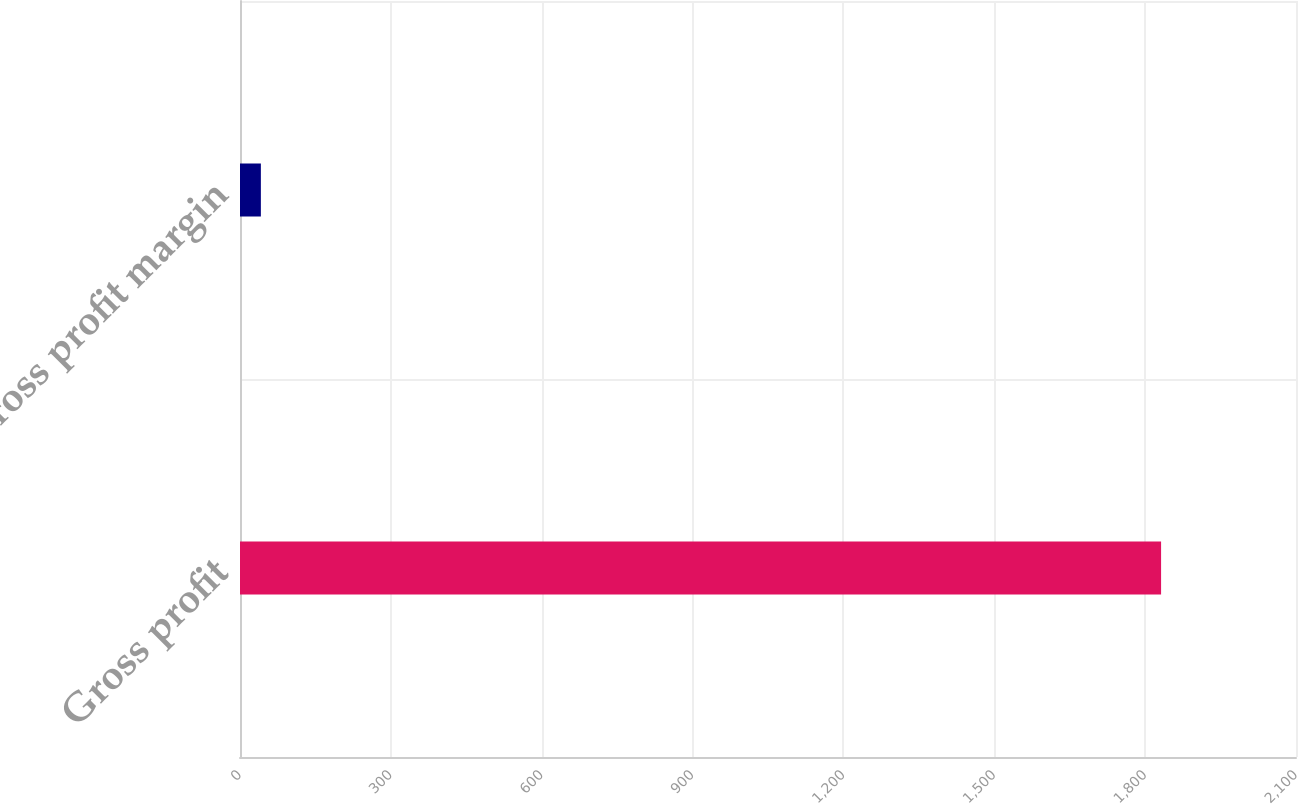<chart> <loc_0><loc_0><loc_500><loc_500><bar_chart><fcel>Gross profit<fcel>Gross profit margin<nl><fcel>1831.7<fcel>41.5<nl></chart> 